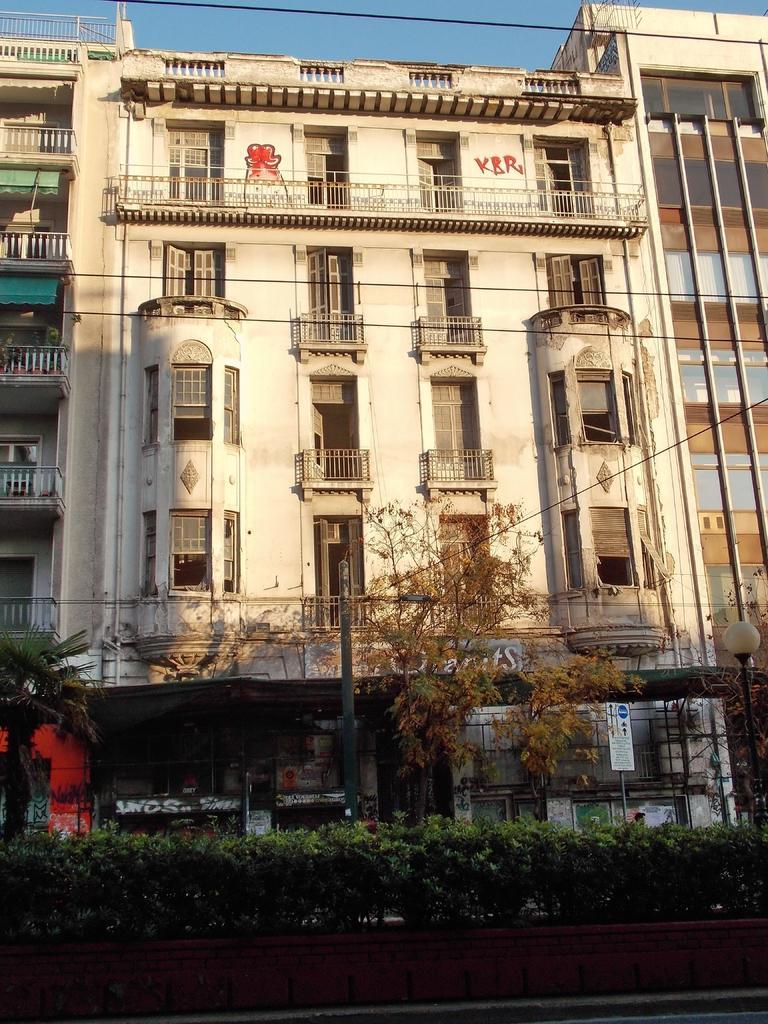Could you give a brief overview of what you see in this image? At the bottom of the picture, we see the flower pots and the plants or shrubs. Behind that, we see trees, pole and a light pole. Behind that, we see the board in white color with some text written on it. There are buildings in the background. We even see the railing and the windows. At the top, we see the sky, which is blue in color. 